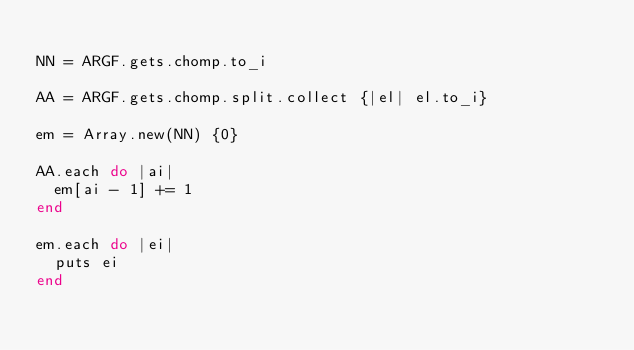<code> <loc_0><loc_0><loc_500><loc_500><_Ruby_>
NN = ARGF.gets.chomp.to_i

AA = ARGF.gets.chomp.split.collect {|el| el.to_i}

em = Array.new(NN) {0}

AA.each do |ai|
  em[ai - 1] += 1
end

em.each do |ei|
  puts ei
end

</code> 